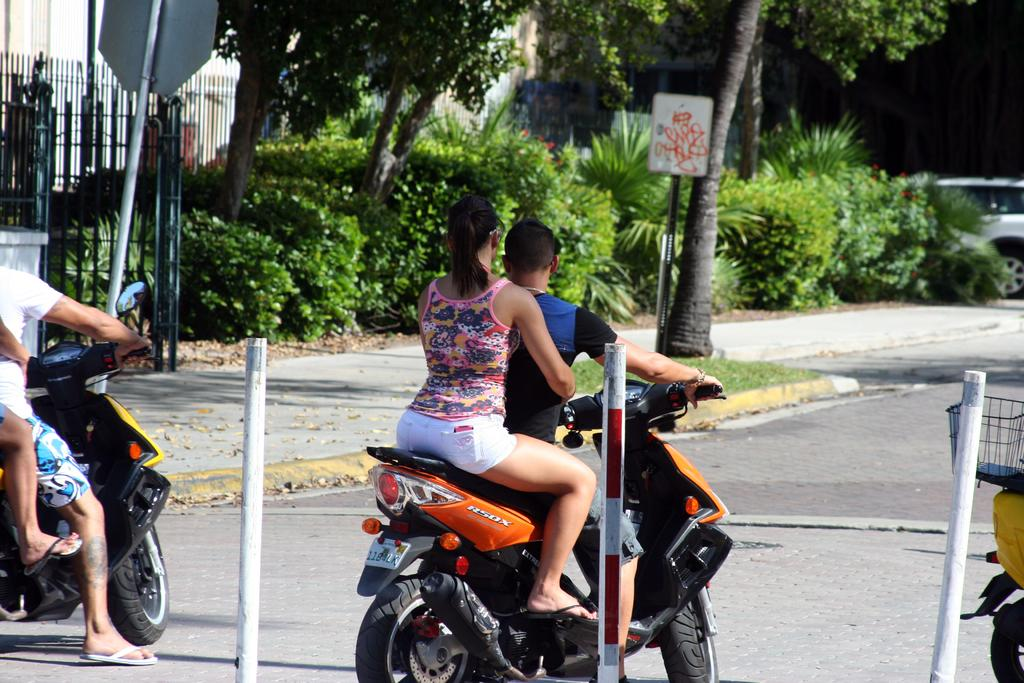How many people are in the image? There are four people in the image. What are the people doing in the image? The people are riding a motorbike. Where is the motorbike located? The motorbike is on the road. What can be seen in the background of the image? There is a car in the background of the image. What is present on the right side of the image? There is a fence and trees on the right side of the image. Can you see the thumb of the person riding the motorbike in the image? There is no visible thumb of the person riding the motorbike in the image. Is there a bridge in the image? There is no bridge present in the image. 